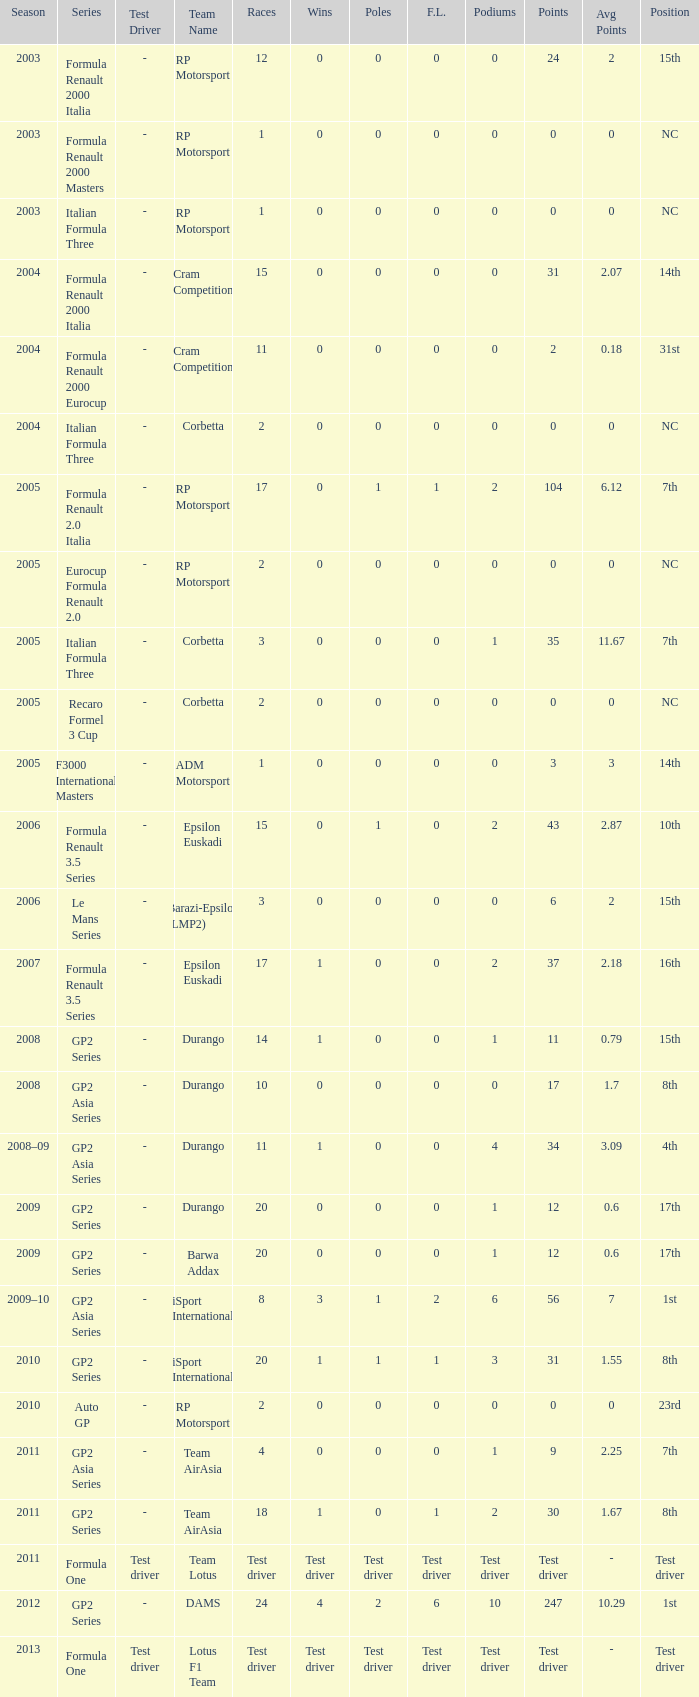What is the number of poles with 4 races? 0.0. 